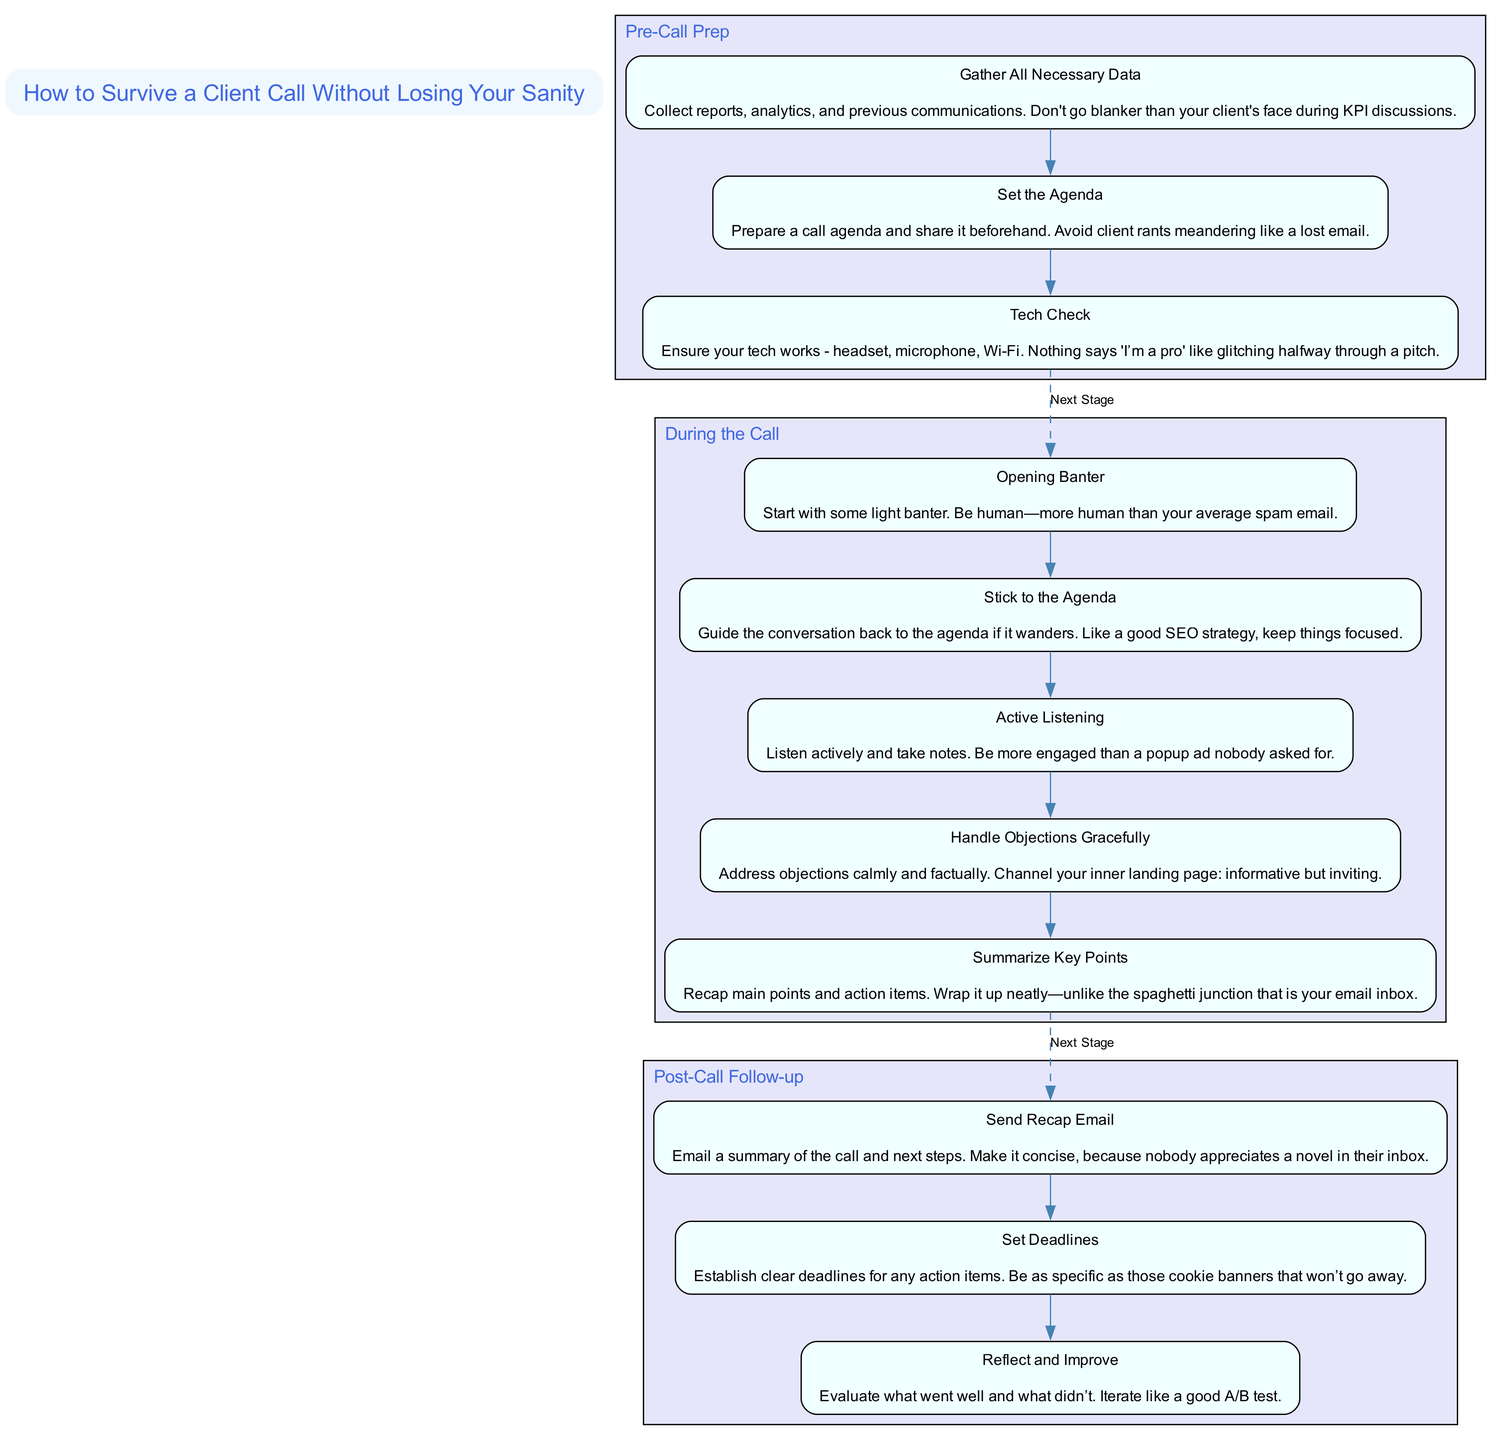What are the actions in the Pre-Call Prep stage? The Pre-Call Prep stage contains three actions: "Gather All Necessary Data", "Set the Agenda", and "Tech Check". These actions are listed directly under the "Pre-Call Prep" section in the diagram.
Answer: "Gather All Necessary Data", "Set the Agenda", "Tech Check" How many actions are there in the During the Call stage? In the During the Call stage, there are five actions presented. They can be counted directly from the nodes corresponding to this stage in the diagram.
Answer: 5 What connects the last action of the Pre-Call Prep to the first action of the During the Call stage? A dashed edge labeled 'Next Stage' connects the last action of the Pre-Call Prep stage to the first action of the During the Call stage. This connection indicates the flow from one stage to the next.
Answer: Next Stage Which action addresses objections during the call? The action that handles objections during the call is "Handle Objections Gracefully". This can be seen in the list of actions within the "During the Call" stage.
Answer: Handle Objections Gracefully What is the first action in the Post-Call Follow-up stage? The first action in the Post-Call Follow-up stage is "Send Recap Email". This information is gathered by identifying the order of actions listed under this stage in the diagram.
Answer: Send Recap Email If the call goes off-topic, which action should you revert to? If the call wanders off-topic, the action you should revert to is "Stick to the Agenda". This action ensures the conversation remains focused, as highlighted in the description of this action.
Answer: Stick to the Agenda How does "Reflect and Improve" contribute to the call process? "Reflect and Improve" contributes by allowing for an evaluation of what went well and what didn’t after the call, serving as a step for continuous improvement. This action emphasizes the iterative nature of the follow-up process described in the diagram.
Answer: Continuous improvement What is emphasized in the "Tech Check" action? The "Tech Check" action emphasizes ensuring all technology works properly for the call, preventing interruptions. This importance is clearly stated in the description of this action in the diagram.
Answer: Proper technology functionality 